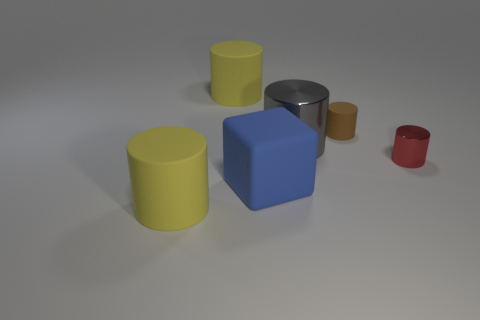There is a gray cylinder; does it have the same size as the yellow object that is in front of the cube?
Give a very brief answer. Yes. How many big objects are red metal cylinders or green metallic cubes?
Keep it short and to the point. 0. How many large blue blocks are there?
Your response must be concise. 1. What is the material of the large yellow cylinder in front of the brown rubber object?
Make the answer very short. Rubber. Are there any large rubber cylinders in front of the brown rubber cylinder?
Offer a terse response. Yes. Is the rubber block the same size as the brown matte object?
Your response must be concise. No. What number of other big things are the same material as the large gray object?
Your answer should be very brief. 0. What size is the brown rubber thing behind the big cylinder that is in front of the small metallic object?
Give a very brief answer. Small. The large cylinder that is behind the large blue block and in front of the brown object is what color?
Offer a terse response. Gray. Is the shape of the red object the same as the tiny rubber object?
Provide a succinct answer. Yes. 